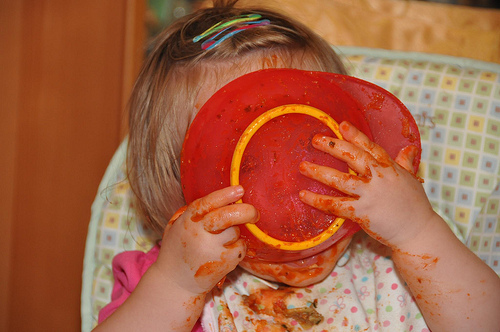<image>
Is the plate on the lips? Yes. Looking at the image, I can see the plate is positioned on top of the lips, with the lips providing support. 